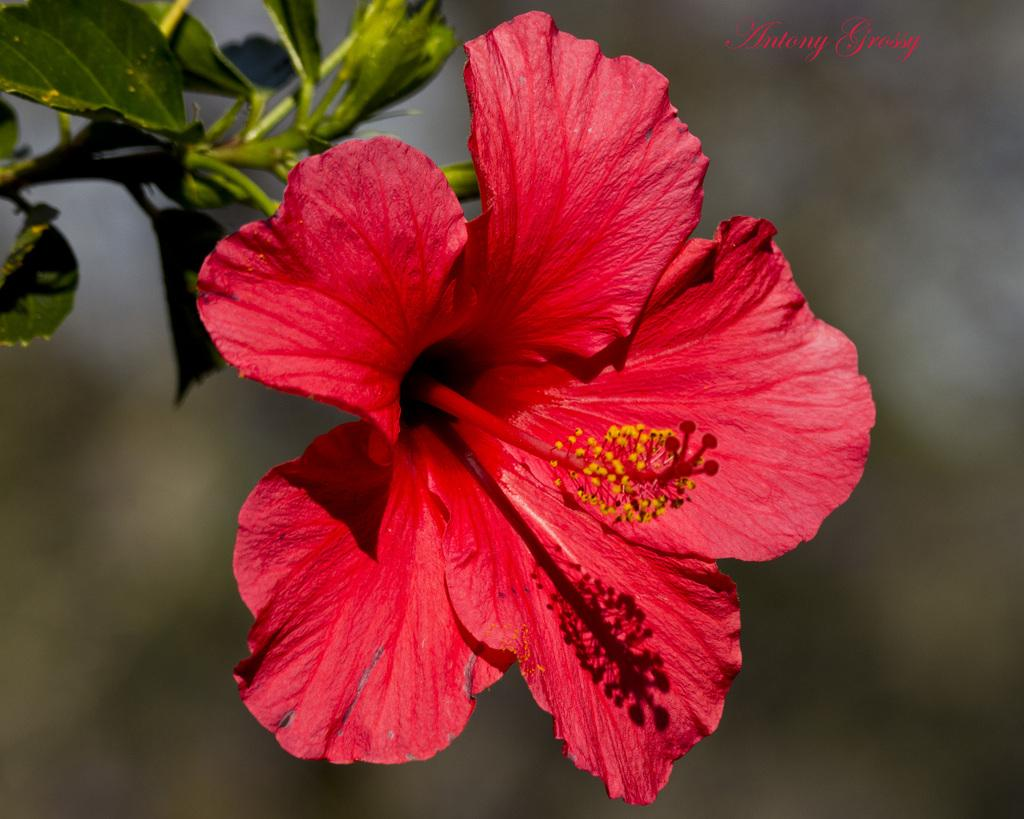What is the main subject of the image? There is a flower in the image. What else can be seen in the image besides the flower? There are leaves and text written on the image. How is the background of the flower depicted? The background of the flower is blurred. Can you see a plane flying in the background of the image? There is no plane visible in the image; it only features a flower, leaves, and text. 